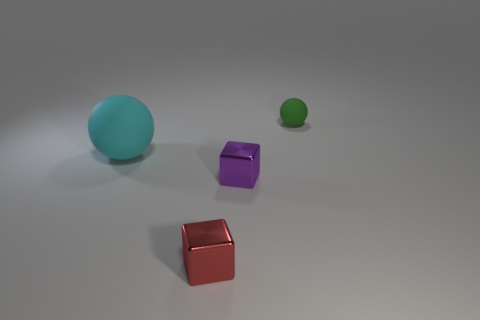Add 1 green objects. How many objects exist? 5 Add 3 blue matte things. How many blue matte things exist? 3 Subtract 1 purple cubes. How many objects are left? 3 Subtract all big cyan balls. Subtract all small gray matte objects. How many objects are left? 3 Add 2 tiny purple blocks. How many tiny purple blocks are left? 3 